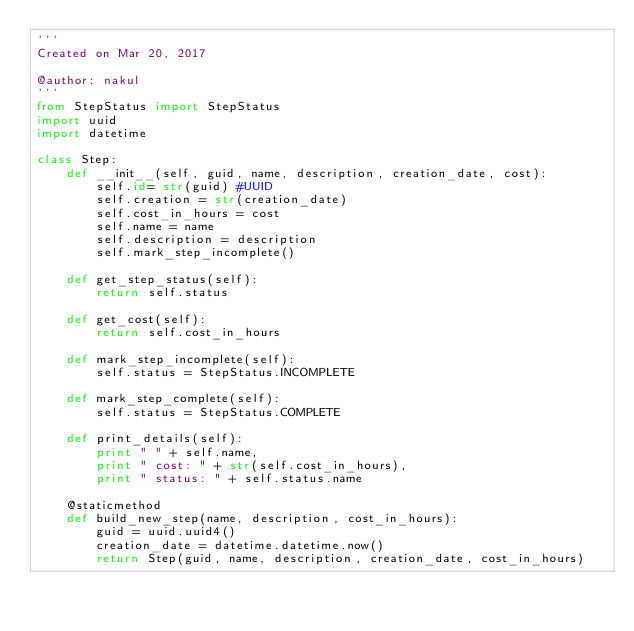Convert code to text. <code><loc_0><loc_0><loc_500><loc_500><_Python_>'''
Created on Mar 20, 2017

@author: nakul
'''
from StepStatus import StepStatus
import uuid
import datetime

class Step:
    def __init__(self, guid, name, description, creation_date, cost):
        self.id= str(guid) #UUID
        self.creation = str(creation_date)
        self.cost_in_hours = cost
        self.name = name
        self.description = description
        self.mark_step_incomplete()

    def get_step_status(self):
        return self.status

    def get_cost(self):
        return self.cost_in_hours

    def mark_step_incomplete(self):
        self.status = StepStatus.INCOMPLETE

    def mark_step_complete(self):
        self.status = StepStatus.COMPLETE

    def print_details(self):
        print " " + self.name,
        print " cost: " + str(self.cost_in_hours),
        print " status: " + self.status.name

    @staticmethod
    def build_new_step(name, description, cost_in_hours):
        guid = uuid.uuid4()
        creation_date = datetime.datetime.now()
        return Step(guid, name, description, creation_date, cost_in_hours)
</code> 